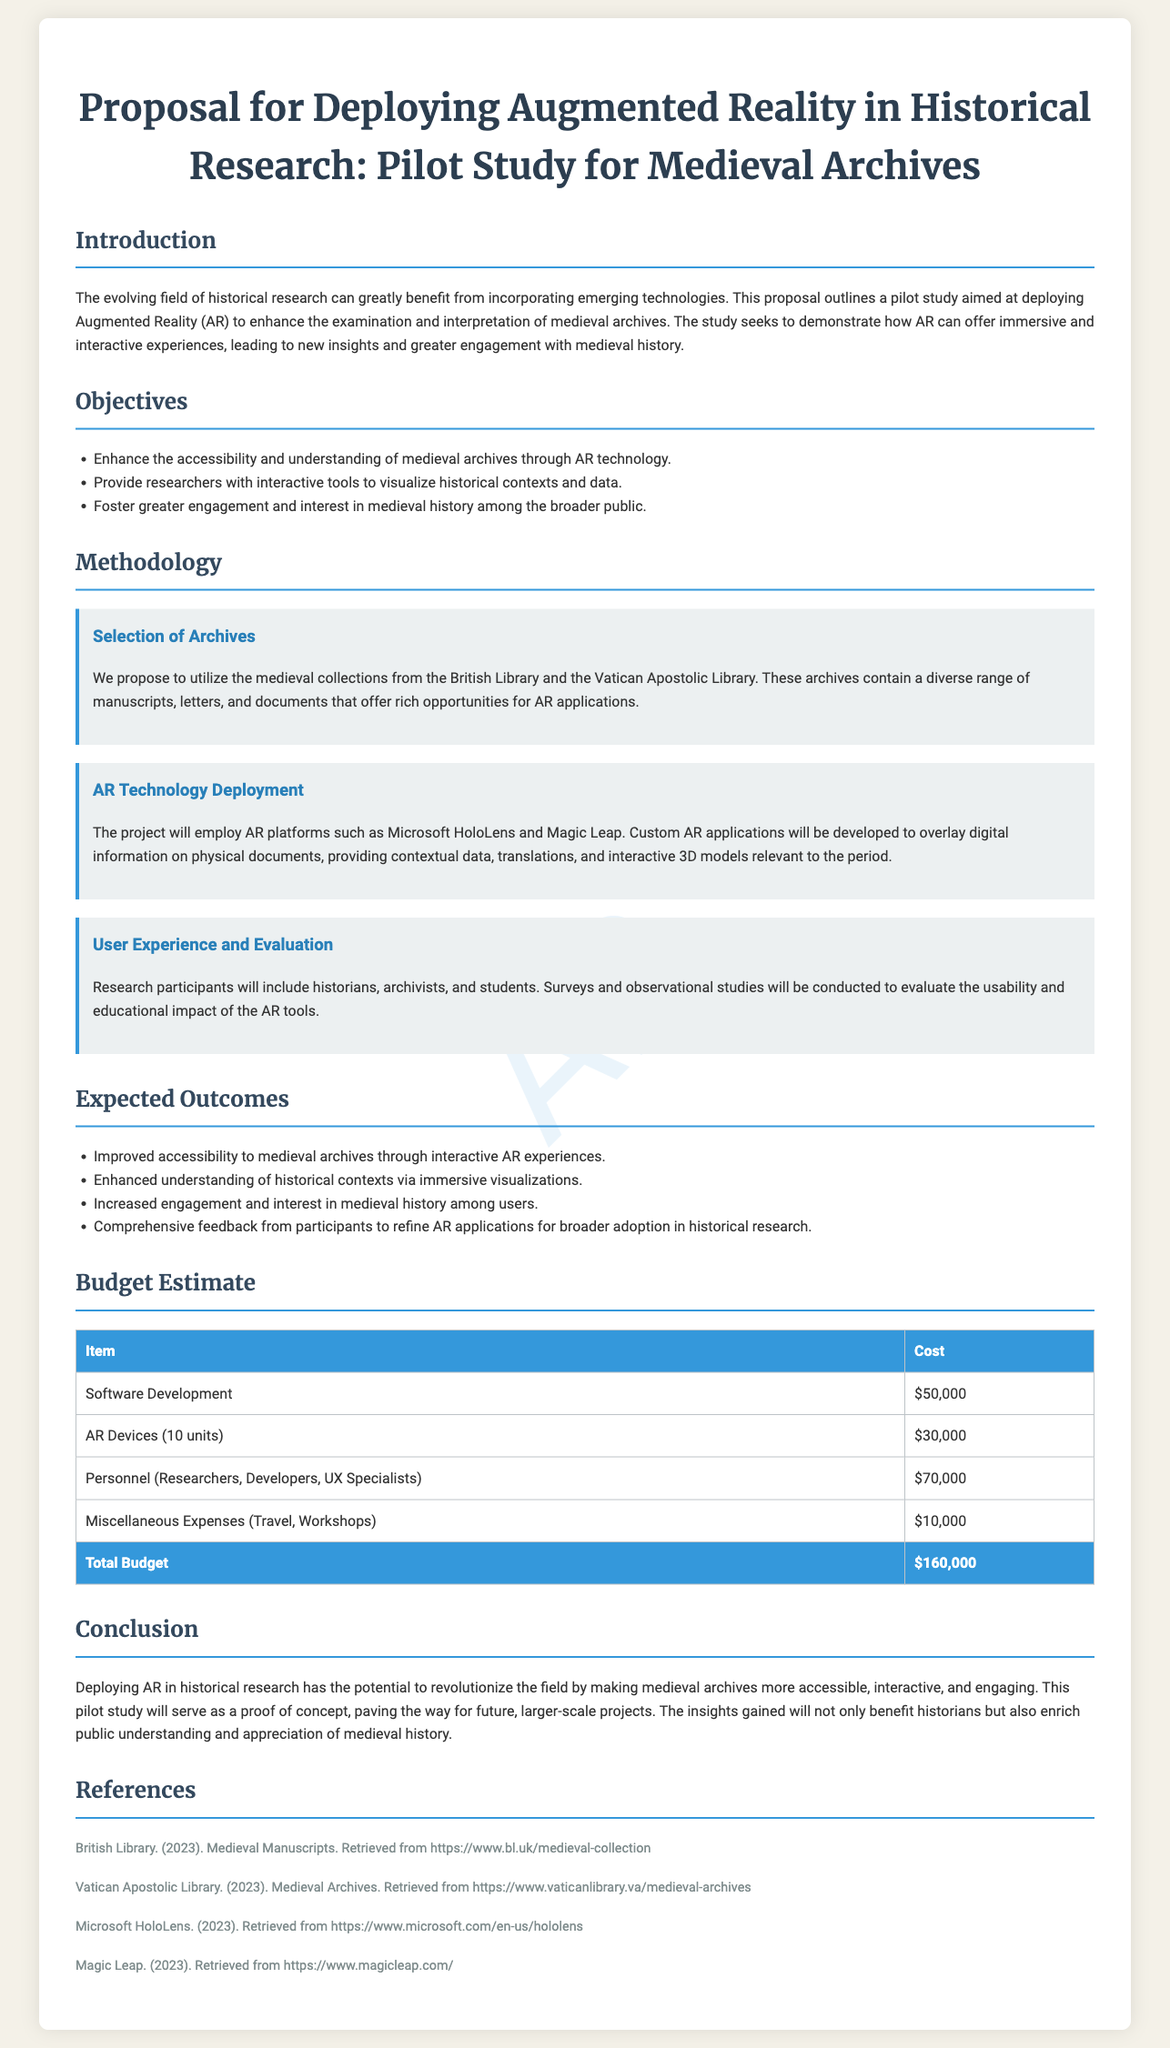What are the objectives of the AR deployment? The objectives of AR deployment include enhancing accessibility, providing interactive tools for visualization, and fostering engagement in medieval history.
Answer: Enhance the accessibility and understanding of medieval archives through AR technology, provide researchers with interactive tools to visualize historical contexts and data, foster greater engagement and interest in medieval history among the broader public Which AR technologies will be used in this study? The proposal specifically mentions the use of Microsoft HoloLens and Magic Leap as the AR platforms.
Answer: Microsoft HoloLens and Magic Leap What is the total budget for the project? The document outlines a detailed budget estimate, with a total budget calculation at the end.
Answer: $160,000 What types of participants will be involved in the user experience evaluation? The participants in the evaluation will include historians, archivists, and students as stated in the methodology section.
Answer: Historians, archivists, and students What is the expected outcome related to public engagement? The expected outcome aims to increase engagement and interest in medieval history among users.
Answer: Increased engagement and interest in medieval history among users What are the miscellaneous expenses listed in the budget? The budget includes a category for miscellaneous expenses, which accounts for specific costs outside of major categories.
Answer: $10,000 